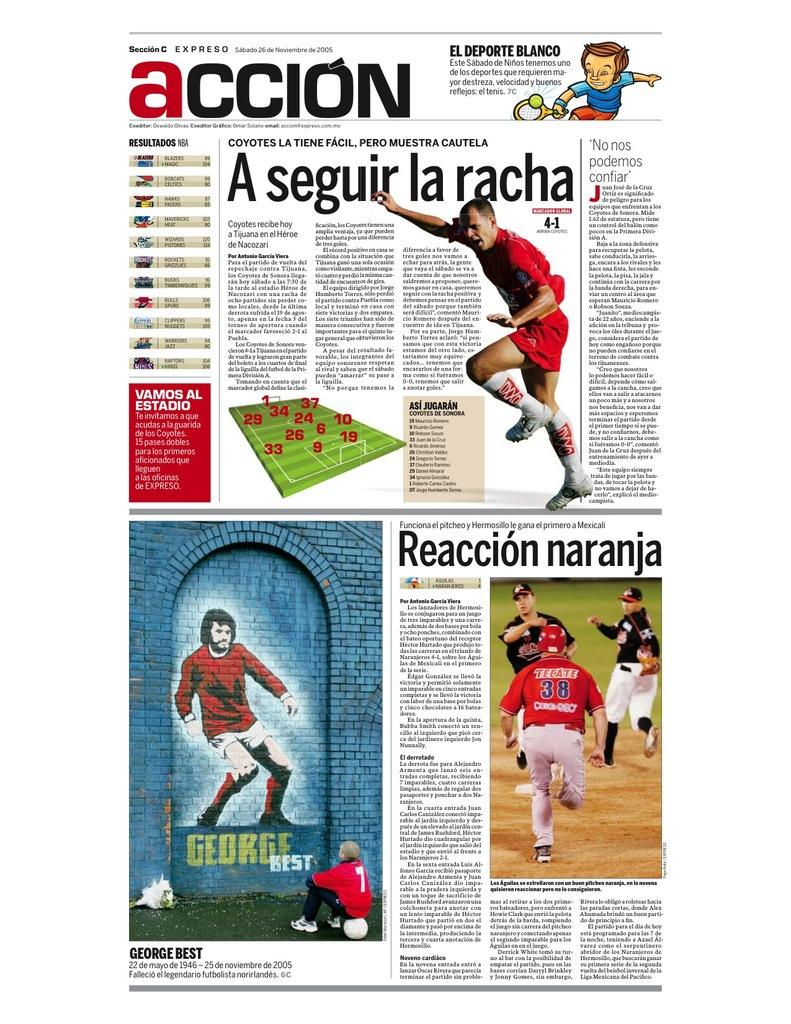<image>
Write a terse but informative summary of the picture. Th name of the publication is Accion and advertises different sports. 